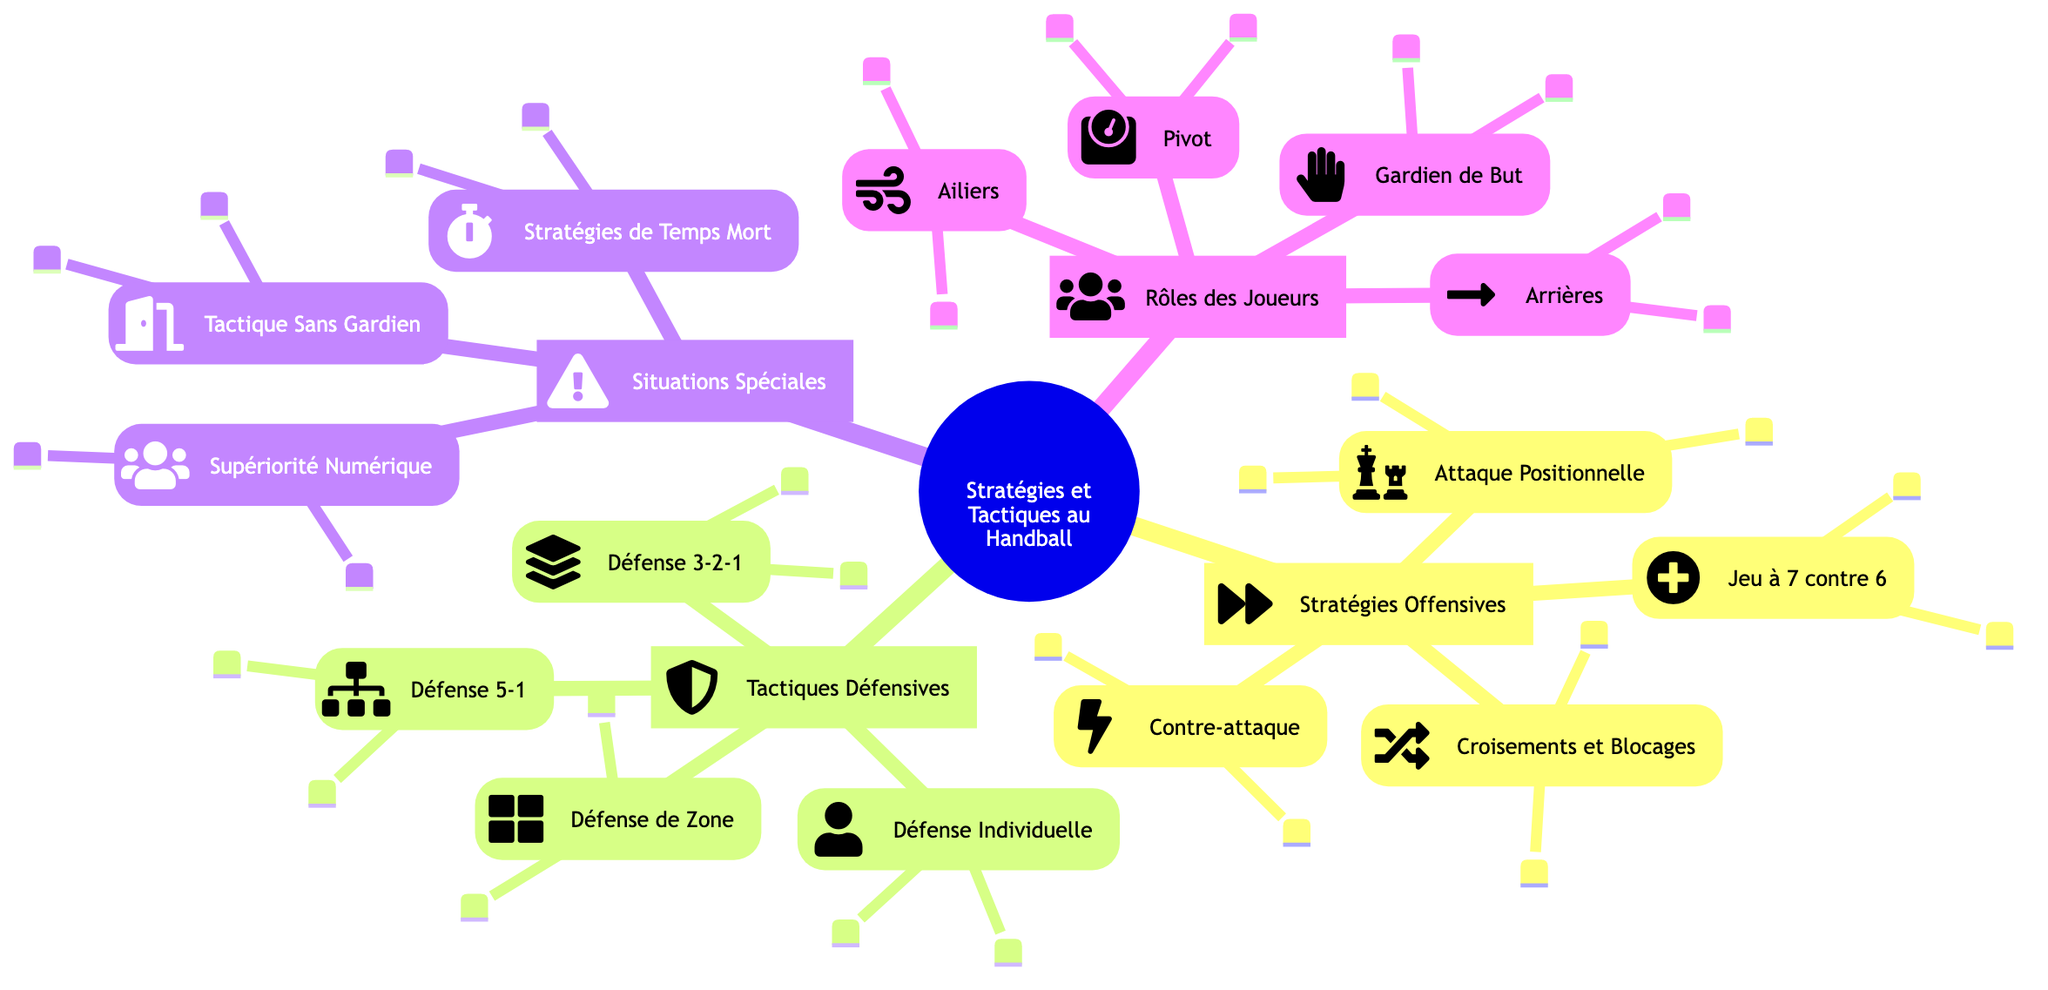What is the central topic of the mind map? The central topic is explicitly stated at the root of the mind map as "Strategies and Tactics in Handball." This can be found at the beginning of the diagram.
Answer: Strategies and Tactics in Handball How many main branches are in the diagram? The main branches originate from the central topic and include four distinct branches: Offensive Strategies, Defensive Tactics, Special Situations, and Player Roles. Counting these branches reveals a total of four main branches.
Answer: 4 What does the "Fast Break" strategy leverage? The details of the "Fast Break" strategy specifically mention it takes advantage of the opponent's disorganization and involves a quick transition. The answer focuses on the key advantage highlighted under this strategy in the diagram.
Answer: Opponent's disorganization What are the common formations in Zone Defense? The "Zone Defense" sub-branch lists common formations directly: 6-0, 5-1, and 4-2. This information can be found under the details section for that tactical approach.
Answer: 6-0, 5-1, 4-2 What is the objective of the Empty Goal Tactic? The "Empty Goal Tactic" details its objective, which is to remove the goalkeeper to introduce an additional outfield player, emphasizing the high-risk, high-reward aspect. Focusing on this aspect shows its main purpose.
Answer: Additional outfield player Which player role is described as a strong physical presence? The "Pivot" player is defined as having a strong physical presence positioned near the opponent’s goal area. This description is present in the details of the Player Roles section.
Answer: Pivot In the 5-1 Defense, how does it respond to attacks? The 5-1 Defense combines zone and man-to-man strategies, providing flexibility in responding to different attacks from the opposing team. This information combines both tactical elements and their purpose.
Answer: Flexibility in responding to attacks What kind of players are Wing Players? Wing Players are characterized by their speed and agility, as stated in their description within the Player Roles section. This provides a direct description of their abilities.
Answer: Speed and agility What is the role of the Goalkeeper in handball? The description of the Goalkeeper highlights their primary role as a defender and their responsibilities include shot stopping and organizing the defense. This information is drawn from their dedicated section in Player Roles.
Answer: Primary defender 